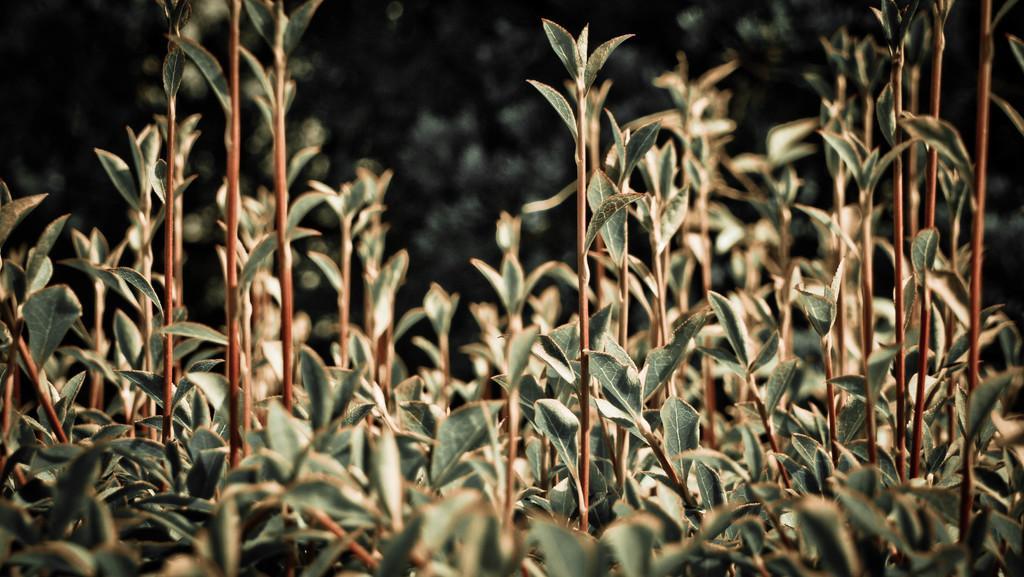In one or two sentences, can you explain what this image depicts? In this image I can see few plants which are green and brown in color and I can see the blurry background which is black and green in color. 